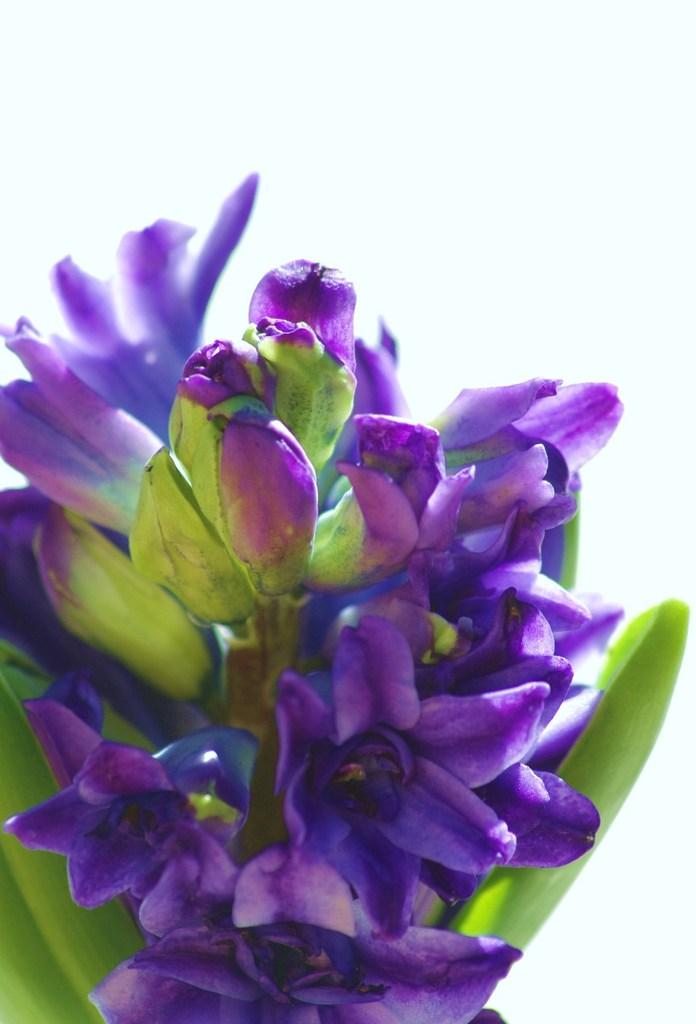What type of flowers can be seen in the image? There are purple flowers in the image. What do the flowers belong to? The flowers belong to a plant. What part of the natural environment is visible in the image? The sky is visible in the image. How many pizzas are being served on the edge of the plant in the image? There are no pizzas present in the image, and the plant does not have an edge. 